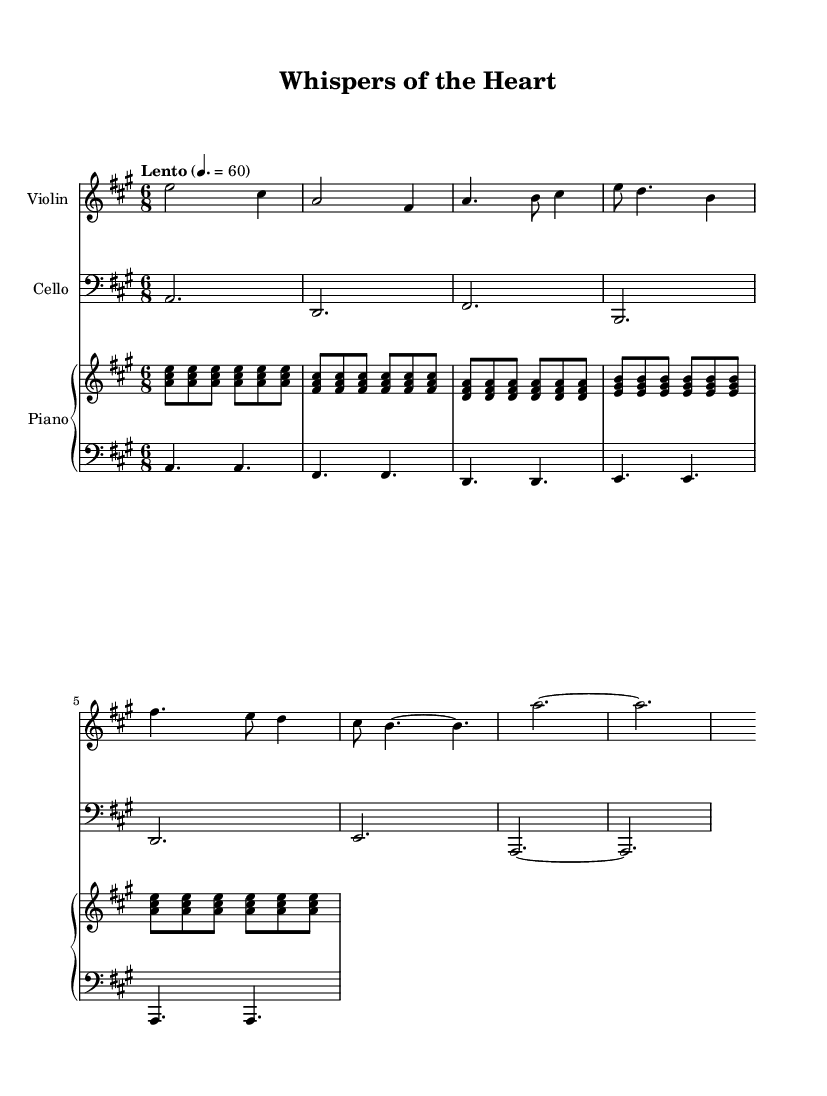What is the key signature of this music? The key signature indicates A major, which has three sharps: F#, C#, and G#. This is visible at the beginning of the sheet music.
Answer: A major What is the time signature of this piece? The time signature is 6/8, as indicated at the start of the score. This means there are six eighth notes per measure.
Answer: 6/8 What is the tempo marking for the piece? The tempo marking states "Lento" with a metronome marking of 60 beats per minute. This indicates a slow tempo.
Answer: Lento How many measures are in the violin part? By counting the number of bar lines in the violin section, there are a total of nine measures present.
Answer: 9 What type of piano accompaniment is used in this piece? The piano part consists of both treble and bass clefs, alternating between harmonic chords in the right hand and a bass line in the left hand, creating an ethereal ambiance.
Answer: Ethereal What is the overall mood conveyed by the music structure? The music features flowing melodies and gentle harmonies, typical of romantic compositions. The use of legato phrases and soft dynamics contributes to an ethereal and dreamy quality.
Answer: Ethereal What instruments are featured in this composition? The score includes three instruments: violin, cello, and piano, which together create a rich textural landscape ideal for representing love themes.
Answer: Violin, cello, piano 